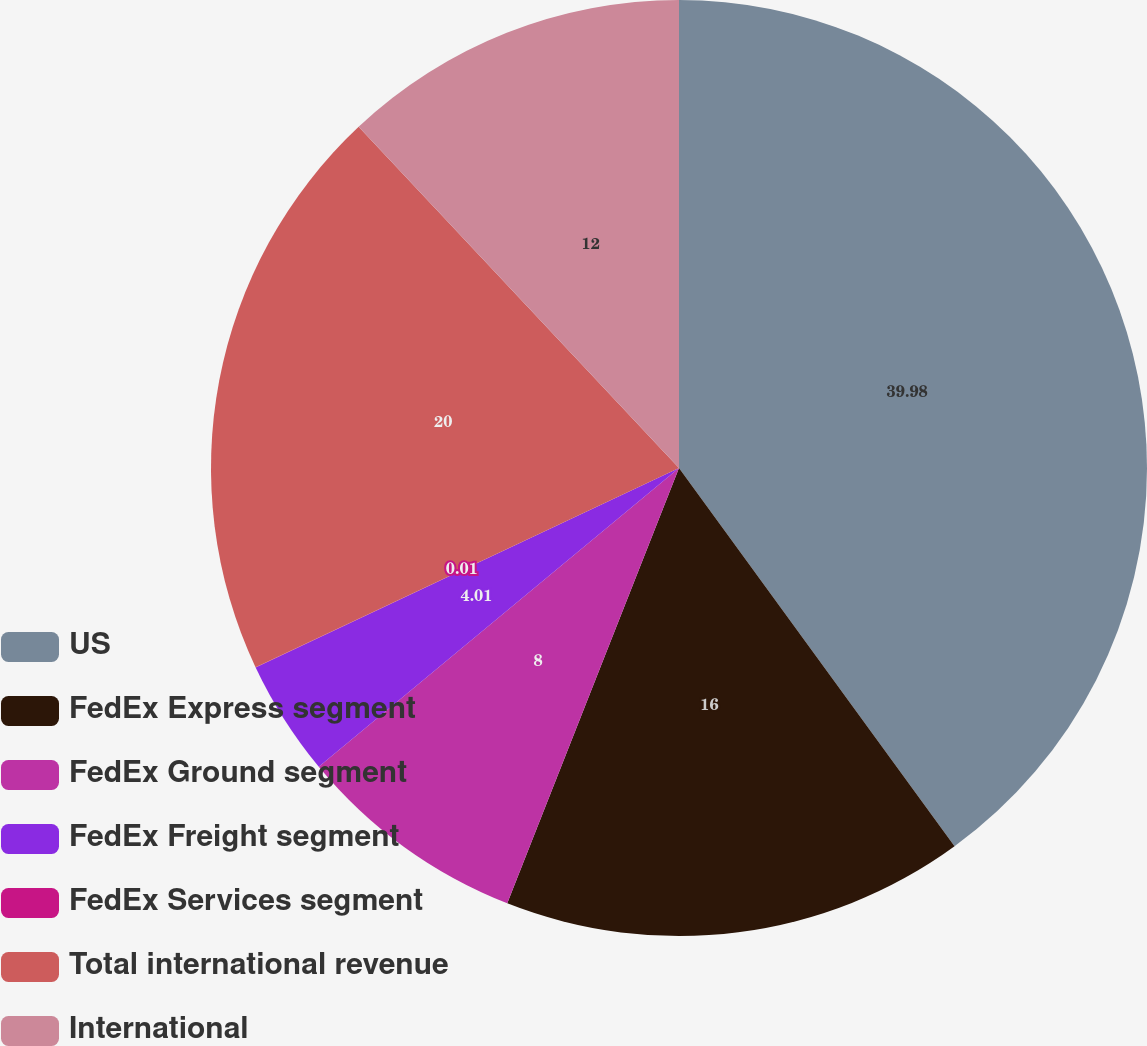Convert chart. <chart><loc_0><loc_0><loc_500><loc_500><pie_chart><fcel>US<fcel>FedEx Express segment<fcel>FedEx Ground segment<fcel>FedEx Freight segment<fcel>FedEx Services segment<fcel>Total international revenue<fcel>International<nl><fcel>39.98%<fcel>16.0%<fcel>8.0%<fcel>4.01%<fcel>0.01%<fcel>20.0%<fcel>12.0%<nl></chart> 